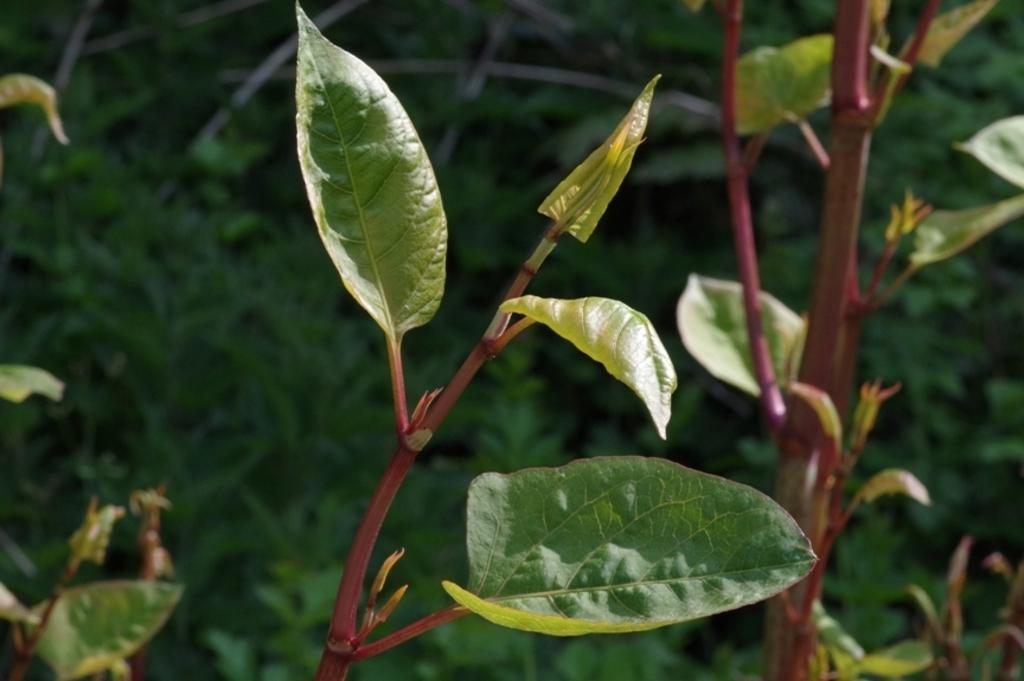Could you give a brief overview of what you see in this image? In this image I can see few green leaves. Background is in green color. 